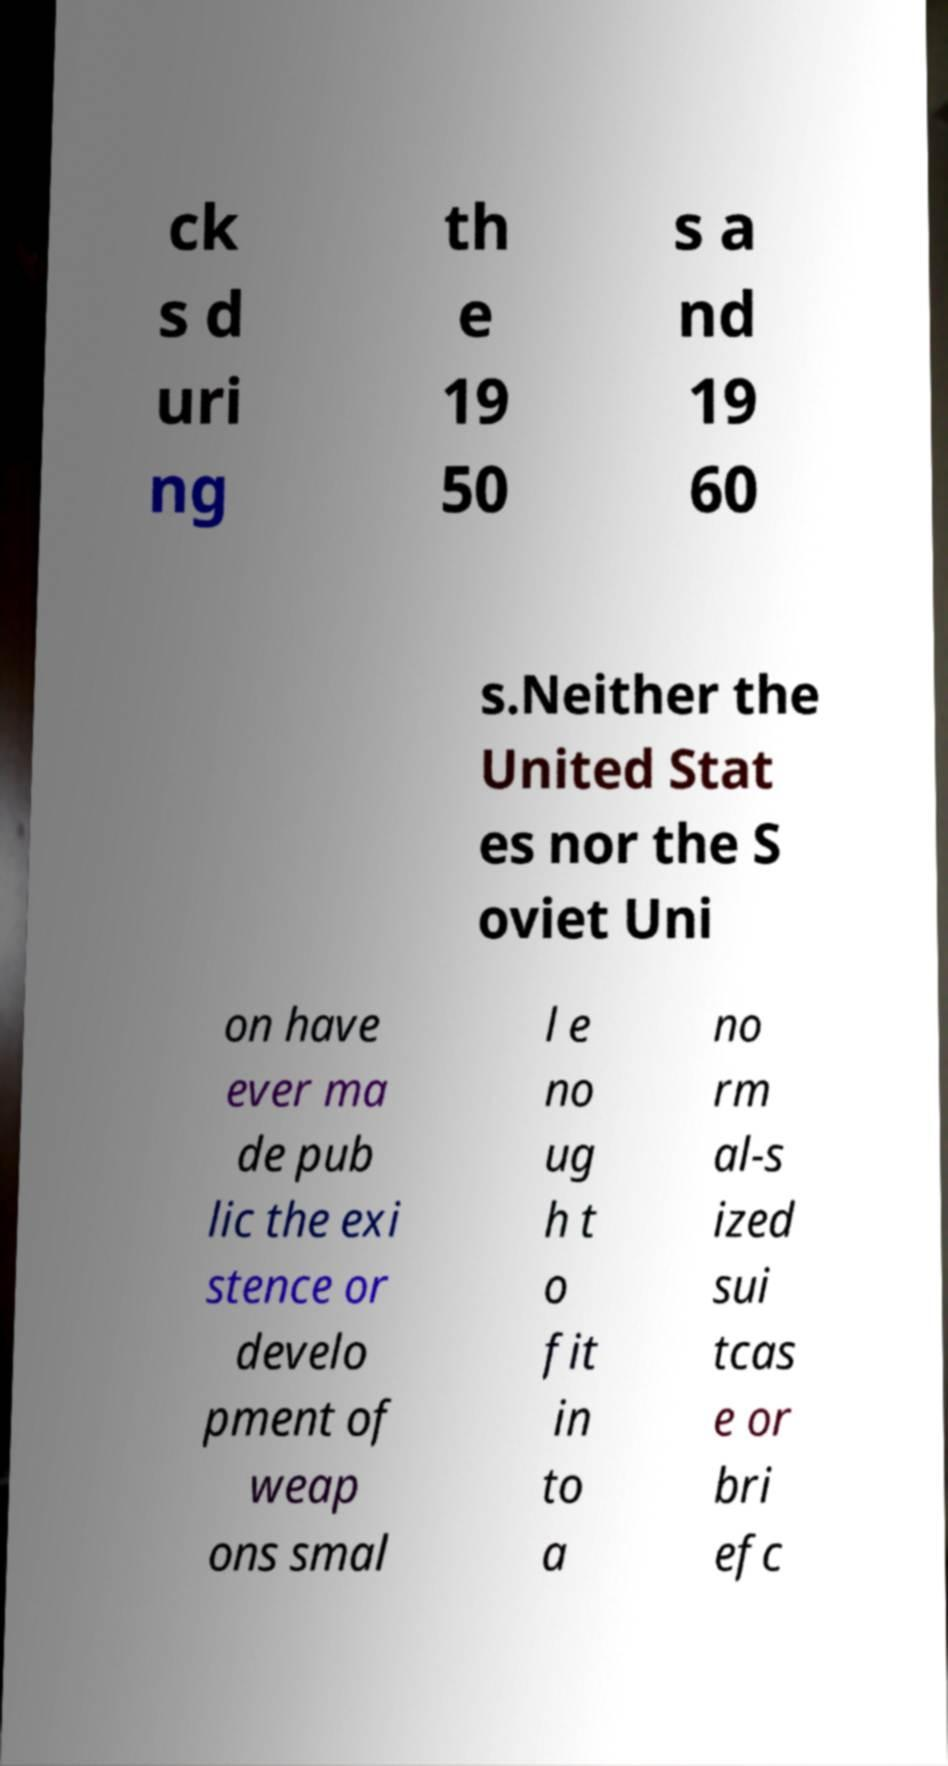Can you read and provide the text displayed in the image?This photo seems to have some interesting text. Can you extract and type it out for me? ck s d uri ng th e 19 50 s a nd 19 60 s.Neither the United Stat es nor the S oviet Uni on have ever ma de pub lic the exi stence or develo pment of weap ons smal l e no ug h t o fit in to a no rm al-s ized sui tcas e or bri efc 